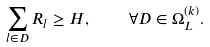<formula> <loc_0><loc_0><loc_500><loc_500>\sum _ { l \in D } R _ { l } \geq H , \quad \forall D \in \Omega _ { L } ^ { ( k ) } .</formula> 